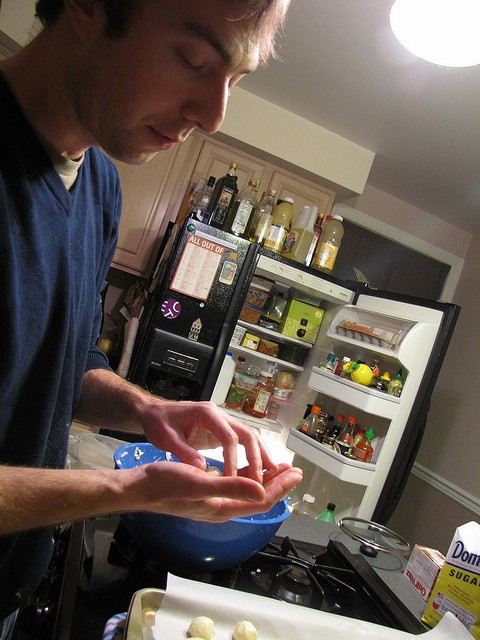Describe the objects in this image and their specific colors. I can see people in black, maroon, navy, and brown tones, refrigerator in black, gray, lightgray, and darkgray tones, oven in black and gray tones, bowl in black, navy, darkblue, and blue tones, and bottle in black, gray, maroon, and darkgray tones in this image. 